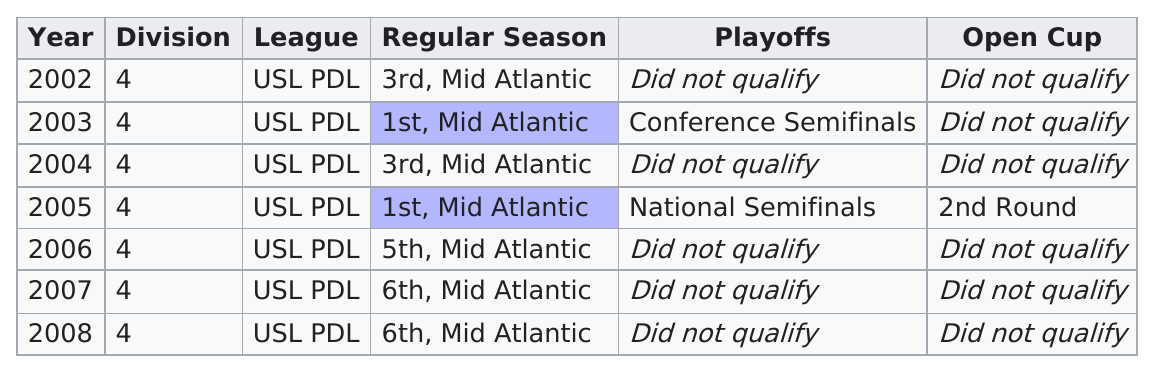Indicate a few pertinent items in this graphic. In the last three years, the Richmond Kickers have received the lowest rank of 6th. The years 2003 and 2004 did not qualify for the study. The Richmond Kickers Future team made it to the national semifinals only once in the year 2005. In 2003, they placed first. In the next year, they placed third. The team qualified for the playoffs two times. 